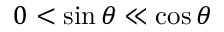<formula> <loc_0><loc_0><loc_500><loc_500>0 < \sin { \theta } \ll \cos { \theta }</formula> 